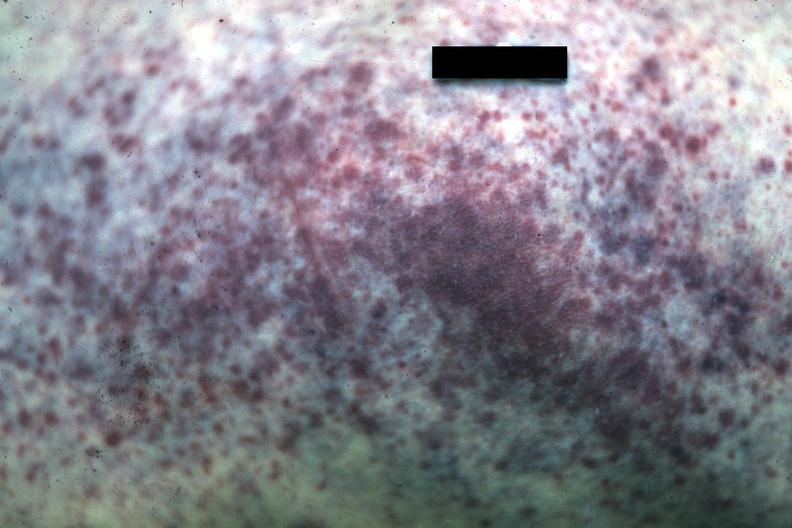s close-up tumor well shown primary not stated present?
Answer the question using a single word or phrase. No 